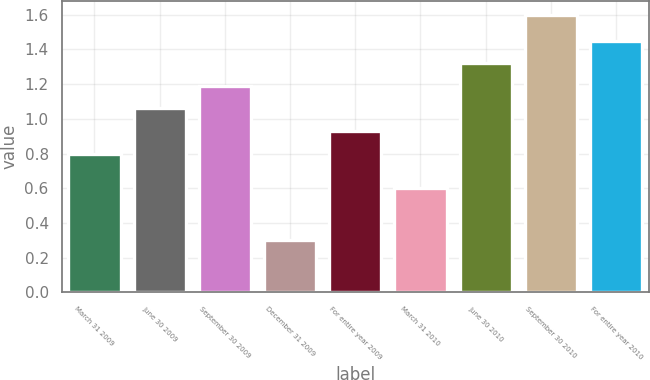<chart> <loc_0><loc_0><loc_500><loc_500><bar_chart><fcel>March 31 2009<fcel>June 30 2009<fcel>September 30 2009<fcel>December 31 2009<fcel>For entire year 2009<fcel>March 31 2010<fcel>June 30 2010<fcel>September 30 2010<fcel>For entire year 2010<nl><fcel>0.8<fcel>1.06<fcel>1.19<fcel>0.3<fcel>0.93<fcel>0.6<fcel>1.32<fcel>1.6<fcel>1.45<nl></chart> 